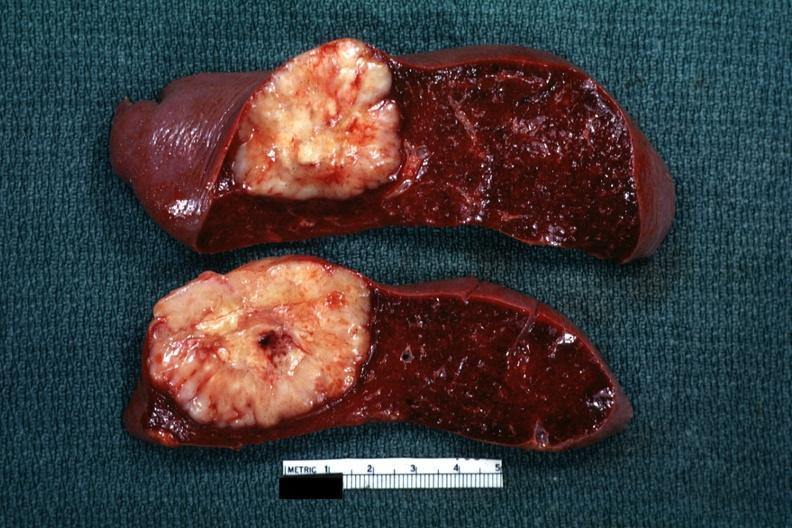s spleen present?
Answer the question using a single word or phrase. Yes 